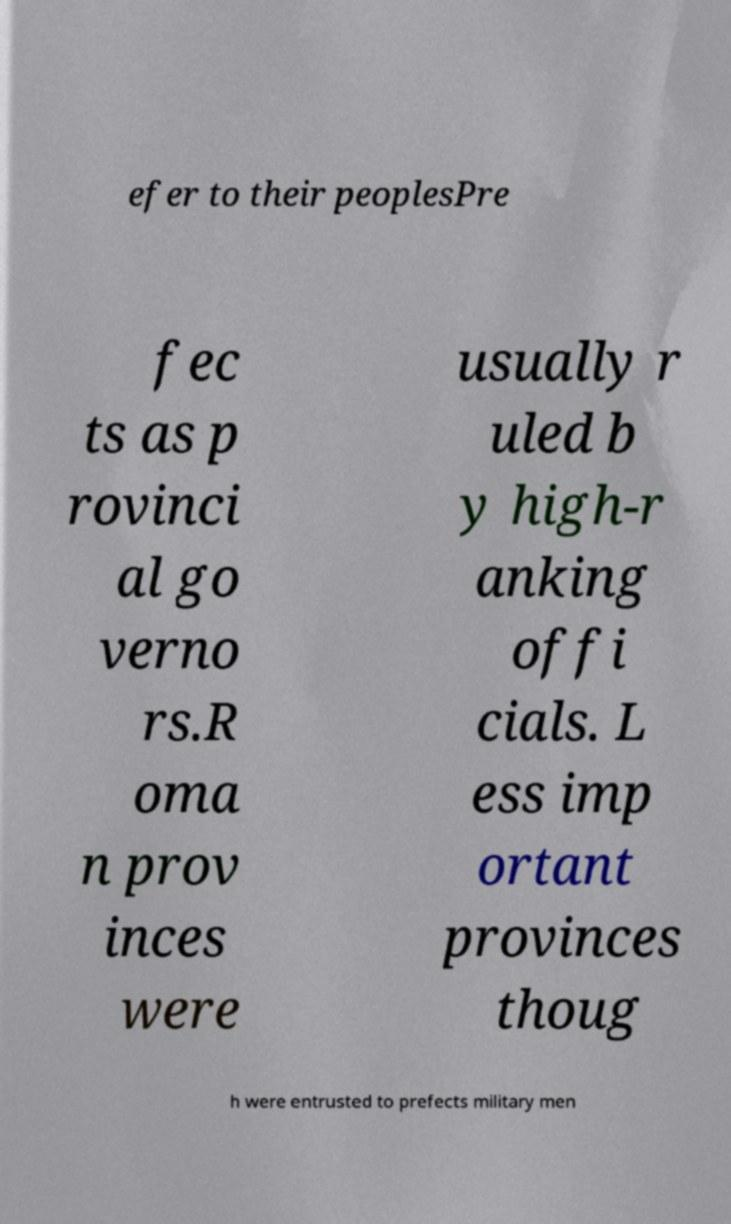Please identify and transcribe the text found in this image. efer to their peoplesPre fec ts as p rovinci al go verno rs.R oma n prov inces were usually r uled b y high-r anking offi cials. L ess imp ortant provinces thoug h were entrusted to prefects military men 